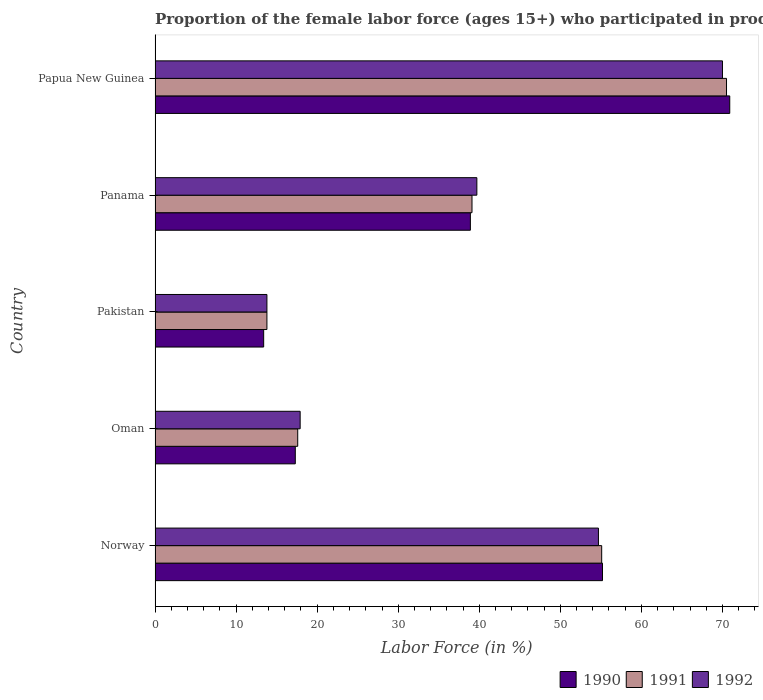Are the number of bars per tick equal to the number of legend labels?
Keep it short and to the point. Yes. Are the number of bars on each tick of the Y-axis equal?
Provide a succinct answer. Yes. How many bars are there on the 2nd tick from the top?
Give a very brief answer. 3. How many bars are there on the 2nd tick from the bottom?
Keep it short and to the point. 3. What is the label of the 4th group of bars from the top?
Your response must be concise. Oman. What is the proportion of the female labor force who participated in production in 1992 in Norway?
Make the answer very short. 54.7. Across all countries, what is the maximum proportion of the female labor force who participated in production in 1990?
Your answer should be compact. 70.9. Across all countries, what is the minimum proportion of the female labor force who participated in production in 1992?
Give a very brief answer. 13.8. In which country was the proportion of the female labor force who participated in production in 1991 maximum?
Provide a succinct answer. Papua New Guinea. In which country was the proportion of the female labor force who participated in production in 1990 minimum?
Your response must be concise. Pakistan. What is the total proportion of the female labor force who participated in production in 1990 in the graph?
Your answer should be compact. 195.7. What is the difference between the proportion of the female labor force who participated in production in 1991 in Norway and that in Papua New Guinea?
Your answer should be compact. -15.4. What is the difference between the proportion of the female labor force who participated in production in 1991 in Pakistan and the proportion of the female labor force who participated in production in 1992 in Oman?
Give a very brief answer. -4.1. What is the average proportion of the female labor force who participated in production in 1990 per country?
Offer a very short reply. 39.14. What is the difference between the proportion of the female labor force who participated in production in 1992 and proportion of the female labor force who participated in production in 1991 in Pakistan?
Your answer should be very brief. 0. In how many countries, is the proportion of the female labor force who participated in production in 1991 greater than 20 %?
Your response must be concise. 3. What is the ratio of the proportion of the female labor force who participated in production in 1992 in Oman to that in Panama?
Offer a very short reply. 0.45. Is the difference between the proportion of the female labor force who participated in production in 1992 in Pakistan and Panama greater than the difference between the proportion of the female labor force who participated in production in 1991 in Pakistan and Panama?
Offer a terse response. No. What is the difference between the highest and the second highest proportion of the female labor force who participated in production in 1990?
Give a very brief answer. 15.7. What is the difference between the highest and the lowest proportion of the female labor force who participated in production in 1991?
Provide a short and direct response. 56.7. In how many countries, is the proportion of the female labor force who participated in production in 1991 greater than the average proportion of the female labor force who participated in production in 1991 taken over all countries?
Offer a very short reply. 2. Is the sum of the proportion of the female labor force who participated in production in 1990 in Oman and Papua New Guinea greater than the maximum proportion of the female labor force who participated in production in 1992 across all countries?
Your answer should be compact. Yes. What does the 2nd bar from the bottom in Oman represents?
Provide a short and direct response. 1991. How many bars are there?
Your answer should be compact. 15. Does the graph contain grids?
Keep it short and to the point. No. Where does the legend appear in the graph?
Your answer should be very brief. Bottom right. How many legend labels are there?
Offer a terse response. 3. How are the legend labels stacked?
Your answer should be very brief. Horizontal. What is the title of the graph?
Offer a very short reply. Proportion of the female labor force (ages 15+) who participated in production. Does "1996" appear as one of the legend labels in the graph?
Your answer should be compact. No. What is the Labor Force (in %) of 1990 in Norway?
Keep it short and to the point. 55.2. What is the Labor Force (in %) in 1991 in Norway?
Give a very brief answer. 55.1. What is the Labor Force (in %) of 1992 in Norway?
Offer a very short reply. 54.7. What is the Labor Force (in %) of 1990 in Oman?
Give a very brief answer. 17.3. What is the Labor Force (in %) of 1991 in Oman?
Ensure brevity in your answer.  17.6. What is the Labor Force (in %) in 1992 in Oman?
Your answer should be compact. 17.9. What is the Labor Force (in %) of 1990 in Pakistan?
Offer a terse response. 13.4. What is the Labor Force (in %) of 1991 in Pakistan?
Ensure brevity in your answer.  13.8. What is the Labor Force (in %) in 1992 in Pakistan?
Ensure brevity in your answer.  13.8. What is the Labor Force (in %) in 1990 in Panama?
Ensure brevity in your answer.  38.9. What is the Labor Force (in %) in 1991 in Panama?
Your answer should be compact. 39.1. What is the Labor Force (in %) in 1992 in Panama?
Your response must be concise. 39.7. What is the Labor Force (in %) in 1990 in Papua New Guinea?
Provide a short and direct response. 70.9. What is the Labor Force (in %) in 1991 in Papua New Guinea?
Your response must be concise. 70.5. What is the Labor Force (in %) in 1992 in Papua New Guinea?
Your response must be concise. 70. Across all countries, what is the maximum Labor Force (in %) in 1990?
Your answer should be very brief. 70.9. Across all countries, what is the maximum Labor Force (in %) in 1991?
Make the answer very short. 70.5. Across all countries, what is the maximum Labor Force (in %) in 1992?
Offer a terse response. 70. Across all countries, what is the minimum Labor Force (in %) of 1990?
Make the answer very short. 13.4. Across all countries, what is the minimum Labor Force (in %) of 1991?
Give a very brief answer. 13.8. Across all countries, what is the minimum Labor Force (in %) of 1992?
Keep it short and to the point. 13.8. What is the total Labor Force (in %) in 1990 in the graph?
Provide a succinct answer. 195.7. What is the total Labor Force (in %) of 1991 in the graph?
Provide a succinct answer. 196.1. What is the total Labor Force (in %) of 1992 in the graph?
Provide a succinct answer. 196.1. What is the difference between the Labor Force (in %) of 1990 in Norway and that in Oman?
Your answer should be very brief. 37.9. What is the difference between the Labor Force (in %) of 1991 in Norway and that in Oman?
Give a very brief answer. 37.5. What is the difference between the Labor Force (in %) in 1992 in Norway and that in Oman?
Ensure brevity in your answer.  36.8. What is the difference between the Labor Force (in %) of 1990 in Norway and that in Pakistan?
Keep it short and to the point. 41.8. What is the difference between the Labor Force (in %) in 1991 in Norway and that in Pakistan?
Keep it short and to the point. 41.3. What is the difference between the Labor Force (in %) in 1992 in Norway and that in Pakistan?
Give a very brief answer. 40.9. What is the difference between the Labor Force (in %) of 1990 in Norway and that in Panama?
Your answer should be very brief. 16.3. What is the difference between the Labor Force (in %) in 1992 in Norway and that in Panama?
Provide a short and direct response. 15. What is the difference between the Labor Force (in %) in 1990 in Norway and that in Papua New Guinea?
Your answer should be compact. -15.7. What is the difference between the Labor Force (in %) of 1991 in Norway and that in Papua New Guinea?
Your answer should be very brief. -15.4. What is the difference between the Labor Force (in %) in 1992 in Norway and that in Papua New Guinea?
Provide a succinct answer. -15.3. What is the difference between the Labor Force (in %) of 1990 in Oman and that in Pakistan?
Give a very brief answer. 3.9. What is the difference between the Labor Force (in %) in 1992 in Oman and that in Pakistan?
Make the answer very short. 4.1. What is the difference between the Labor Force (in %) of 1990 in Oman and that in Panama?
Ensure brevity in your answer.  -21.6. What is the difference between the Labor Force (in %) of 1991 in Oman and that in Panama?
Give a very brief answer. -21.5. What is the difference between the Labor Force (in %) in 1992 in Oman and that in Panama?
Provide a succinct answer. -21.8. What is the difference between the Labor Force (in %) of 1990 in Oman and that in Papua New Guinea?
Provide a succinct answer. -53.6. What is the difference between the Labor Force (in %) in 1991 in Oman and that in Papua New Guinea?
Keep it short and to the point. -52.9. What is the difference between the Labor Force (in %) in 1992 in Oman and that in Papua New Guinea?
Your answer should be compact. -52.1. What is the difference between the Labor Force (in %) of 1990 in Pakistan and that in Panama?
Provide a succinct answer. -25.5. What is the difference between the Labor Force (in %) in 1991 in Pakistan and that in Panama?
Offer a very short reply. -25.3. What is the difference between the Labor Force (in %) in 1992 in Pakistan and that in Panama?
Give a very brief answer. -25.9. What is the difference between the Labor Force (in %) of 1990 in Pakistan and that in Papua New Guinea?
Keep it short and to the point. -57.5. What is the difference between the Labor Force (in %) in 1991 in Pakistan and that in Papua New Guinea?
Provide a short and direct response. -56.7. What is the difference between the Labor Force (in %) in 1992 in Pakistan and that in Papua New Guinea?
Your answer should be very brief. -56.2. What is the difference between the Labor Force (in %) of 1990 in Panama and that in Papua New Guinea?
Offer a terse response. -32. What is the difference between the Labor Force (in %) of 1991 in Panama and that in Papua New Guinea?
Provide a short and direct response. -31.4. What is the difference between the Labor Force (in %) in 1992 in Panama and that in Papua New Guinea?
Provide a succinct answer. -30.3. What is the difference between the Labor Force (in %) of 1990 in Norway and the Labor Force (in %) of 1991 in Oman?
Ensure brevity in your answer.  37.6. What is the difference between the Labor Force (in %) in 1990 in Norway and the Labor Force (in %) in 1992 in Oman?
Your response must be concise. 37.3. What is the difference between the Labor Force (in %) in 1991 in Norway and the Labor Force (in %) in 1992 in Oman?
Keep it short and to the point. 37.2. What is the difference between the Labor Force (in %) of 1990 in Norway and the Labor Force (in %) of 1991 in Pakistan?
Keep it short and to the point. 41.4. What is the difference between the Labor Force (in %) of 1990 in Norway and the Labor Force (in %) of 1992 in Pakistan?
Your answer should be very brief. 41.4. What is the difference between the Labor Force (in %) in 1991 in Norway and the Labor Force (in %) in 1992 in Pakistan?
Give a very brief answer. 41.3. What is the difference between the Labor Force (in %) of 1990 in Norway and the Labor Force (in %) of 1991 in Panama?
Provide a short and direct response. 16.1. What is the difference between the Labor Force (in %) of 1990 in Norway and the Labor Force (in %) of 1992 in Panama?
Your response must be concise. 15.5. What is the difference between the Labor Force (in %) of 1990 in Norway and the Labor Force (in %) of 1991 in Papua New Guinea?
Your answer should be compact. -15.3. What is the difference between the Labor Force (in %) in 1990 in Norway and the Labor Force (in %) in 1992 in Papua New Guinea?
Provide a short and direct response. -14.8. What is the difference between the Labor Force (in %) of 1991 in Norway and the Labor Force (in %) of 1992 in Papua New Guinea?
Ensure brevity in your answer.  -14.9. What is the difference between the Labor Force (in %) in 1990 in Oman and the Labor Force (in %) in 1992 in Pakistan?
Give a very brief answer. 3.5. What is the difference between the Labor Force (in %) of 1990 in Oman and the Labor Force (in %) of 1991 in Panama?
Offer a very short reply. -21.8. What is the difference between the Labor Force (in %) of 1990 in Oman and the Labor Force (in %) of 1992 in Panama?
Ensure brevity in your answer.  -22.4. What is the difference between the Labor Force (in %) of 1991 in Oman and the Labor Force (in %) of 1992 in Panama?
Give a very brief answer. -22.1. What is the difference between the Labor Force (in %) of 1990 in Oman and the Labor Force (in %) of 1991 in Papua New Guinea?
Keep it short and to the point. -53.2. What is the difference between the Labor Force (in %) in 1990 in Oman and the Labor Force (in %) in 1992 in Papua New Guinea?
Provide a short and direct response. -52.7. What is the difference between the Labor Force (in %) in 1991 in Oman and the Labor Force (in %) in 1992 in Papua New Guinea?
Your answer should be very brief. -52.4. What is the difference between the Labor Force (in %) of 1990 in Pakistan and the Labor Force (in %) of 1991 in Panama?
Provide a short and direct response. -25.7. What is the difference between the Labor Force (in %) of 1990 in Pakistan and the Labor Force (in %) of 1992 in Panama?
Keep it short and to the point. -26.3. What is the difference between the Labor Force (in %) of 1991 in Pakistan and the Labor Force (in %) of 1992 in Panama?
Provide a short and direct response. -25.9. What is the difference between the Labor Force (in %) in 1990 in Pakistan and the Labor Force (in %) in 1991 in Papua New Guinea?
Your answer should be compact. -57.1. What is the difference between the Labor Force (in %) of 1990 in Pakistan and the Labor Force (in %) of 1992 in Papua New Guinea?
Offer a terse response. -56.6. What is the difference between the Labor Force (in %) of 1991 in Pakistan and the Labor Force (in %) of 1992 in Papua New Guinea?
Offer a terse response. -56.2. What is the difference between the Labor Force (in %) in 1990 in Panama and the Labor Force (in %) in 1991 in Papua New Guinea?
Ensure brevity in your answer.  -31.6. What is the difference between the Labor Force (in %) in 1990 in Panama and the Labor Force (in %) in 1992 in Papua New Guinea?
Your answer should be very brief. -31.1. What is the difference between the Labor Force (in %) of 1991 in Panama and the Labor Force (in %) of 1992 in Papua New Guinea?
Your answer should be compact. -30.9. What is the average Labor Force (in %) in 1990 per country?
Provide a short and direct response. 39.14. What is the average Labor Force (in %) in 1991 per country?
Ensure brevity in your answer.  39.22. What is the average Labor Force (in %) in 1992 per country?
Your answer should be compact. 39.22. What is the difference between the Labor Force (in %) of 1990 and Labor Force (in %) of 1991 in Norway?
Ensure brevity in your answer.  0.1. What is the difference between the Labor Force (in %) in 1991 and Labor Force (in %) in 1992 in Norway?
Your answer should be compact. 0.4. What is the difference between the Labor Force (in %) of 1990 and Labor Force (in %) of 1992 in Oman?
Offer a terse response. -0.6. What is the difference between the Labor Force (in %) of 1990 and Labor Force (in %) of 1991 in Pakistan?
Provide a succinct answer. -0.4. What is the difference between the Labor Force (in %) of 1990 and Labor Force (in %) of 1991 in Panama?
Your response must be concise. -0.2. What is the difference between the Labor Force (in %) in 1990 and Labor Force (in %) in 1992 in Panama?
Your answer should be compact. -0.8. What is the difference between the Labor Force (in %) of 1990 and Labor Force (in %) of 1991 in Papua New Guinea?
Ensure brevity in your answer.  0.4. What is the difference between the Labor Force (in %) in 1990 and Labor Force (in %) in 1992 in Papua New Guinea?
Your answer should be compact. 0.9. What is the difference between the Labor Force (in %) of 1991 and Labor Force (in %) of 1992 in Papua New Guinea?
Make the answer very short. 0.5. What is the ratio of the Labor Force (in %) in 1990 in Norway to that in Oman?
Your answer should be very brief. 3.19. What is the ratio of the Labor Force (in %) in 1991 in Norway to that in Oman?
Provide a succinct answer. 3.13. What is the ratio of the Labor Force (in %) of 1992 in Norway to that in Oman?
Provide a succinct answer. 3.06. What is the ratio of the Labor Force (in %) in 1990 in Norway to that in Pakistan?
Provide a short and direct response. 4.12. What is the ratio of the Labor Force (in %) of 1991 in Norway to that in Pakistan?
Make the answer very short. 3.99. What is the ratio of the Labor Force (in %) in 1992 in Norway to that in Pakistan?
Keep it short and to the point. 3.96. What is the ratio of the Labor Force (in %) in 1990 in Norway to that in Panama?
Ensure brevity in your answer.  1.42. What is the ratio of the Labor Force (in %) of 1991 in Norway to that in Panama?
Provide a succinct answer. 1.41. What is the ratio of the Labor Force (in %) in 1992 in Norway to that in Panama?
Ensure brevity in your answer.  1.38. What is the ratio of the Labor Force (in %) in 1990 in Norway to that in Papua New Guinea?
Offer a very short reply. 0.78. What is the ratio of the Labor Force (in %) of 1991 in Norway to that in Papua New Guinea?
Give a very brief answer. 0.78. What is the ratio of the Labor Force (in %) of 1992 in Norway to that in Papua New Guinea?
Keep it short and to the point. 0.78. What is the ratio of the Labor Force (in %) of 1990 in Oman to that in Pakistan?
Your answer should be compact. 1.29. What is the ratio of the Labor Force (in %) in 1991 in Oman to that in Pakistan?
Your response must be concise. 1.28. What is the ratio of the Labor Force (in %) in 1992 in Oman to that in Pakistan?
Ensure brevity in your answer.  1.3. What is the ratio of the Labor Force (in %) in 1990 in Oman to that in Panama?
Give a very brief answer. 0.44. What is the ratio of the Labor Force (in %) of 1991 in Oman to that in Panama?
Make the answer very short. 0.45. What is the ratio of the Labor Force (in %) in 1992 in Oman to that in Panama?
Keep it short and to the point. 0.45. What is the ratio of the Labor Force (in %) in 1990 in Oman to that in Papua New Guinea?
Make the answer very short. 0.24. What is the ratio of the Labor Force (in %) in 1991 in Oman to that in Papua New Guinea?
Your response must be concise. 0.25. What is the ratio of the Labor Force (in %) in 1992 in Oman to that in Papua New Guinea?
Give a very brief answer. 0.26. What is the ratio of the Labor Force (in %) of 1990 in Pakistan to that in Panama?
Your answer should be compact. 0.34. What is the ratio of the Labor Force (in %) in 1991 in Pakistan to that in Panama?
Make the answer very short. 0.35. What is the ratio of the Labor Force (in %) in 1992 in Pakistan to that in Panama?
Your answer should be very brief. 0.35. What is the ratio of the Labor Force (in %) of 1990 in Pakistan to that in Papua New Guinea?
Offer a very short reply. 0.19. What is the ratio of the Labor Force (in %) of 1991 in Pakistan to that in Papua New Guinea?
Ensure brevity in your answer.  0.2. What is the ratio of the Labor Force (in %) in 1992 in Pakistan to that in Papua New Guinea?
Your response must be concise. 0.2. What is the ratio of the Labor Force (in %) of 1990 in Panama to that in Papua New Guinea?
Offer a terse response. 0.55. What is the ratio of the Labor Force (in %) of 1991 in Panama to that in Papua New Guinea?
Your answer should be very brief. 0.55. What is the ratio of the Labor Force (in %) of 1992 in Panama to that in Papua New Guinea?
Ensure brevity in your answer.  0.57. What is the difference between the highest and the second highest Labor Force (in %) of 1990?
Your answer should be compact. 15.7. What is the difference between the highest and the lowest Labor Force (in %) of 1990?
Keep it short and to the point. 57.5. What is the difference between the highest and the lowest Labor Force (in %) in 1991?
Keep it short and to the point. 56.7. What is the difference between the highest and the lowest Labor Force (in %) in 1992?
Offer a very short reply. 56.2. 